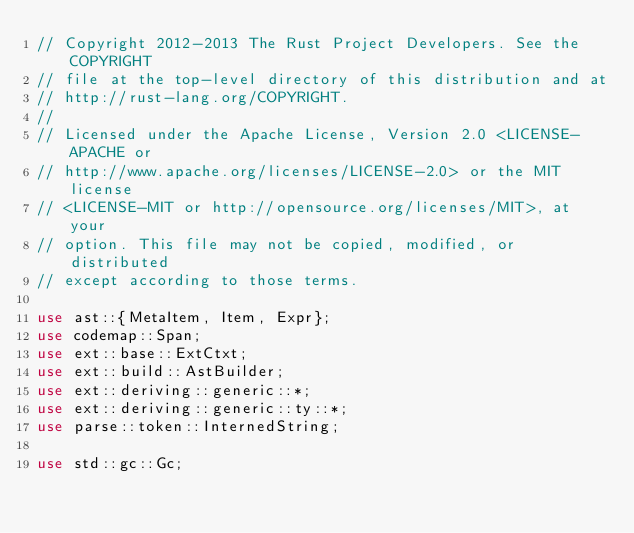Convert code to text. <code><loc_0><loc_0><loc_500><loc_500><_Rust_>// Copyright 2012-2013 The Rust Project Developers. See the COPYRIGHT
// file at the top-level directory of this distribution and at
// http://rust-lang.org/COPYRIGHT.
//
// Licensed under the Apache License, Version 2.0 <LICENSE-APACHE or
// http://www.apache.org/licenses/LICENSE-2.0> or the MIT license
// <LICENSE-MIT or http://opensource.org/licenses/MIT>, at your
// option. This file may not be copied, modified, or distributed
// except according to those terms.

use ast::{MetaItem, Item, Expr};
use codemap::Span;
use ext::base::ExtCtxt;
use ext::build::AstBuilder;
use ext::deriving::generic::*;
use ext::deriving::generic::ty::*;
use parse::token::InternedString;

use std::gc::Gc;
</code> 